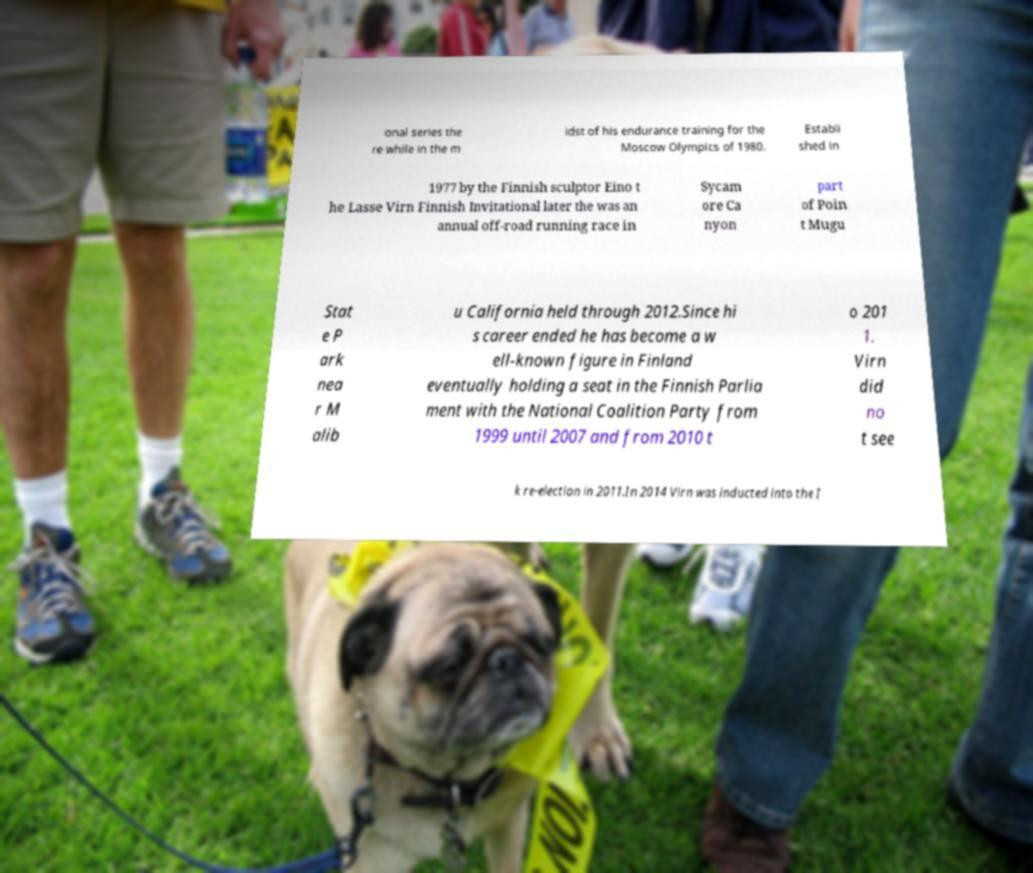Could you extract and type out the text from this image? onal series the re while in the m idst of his endurance training for the Moscow Olympics of 1980. Establi shed in 1977 by the Finnish sculptor Eino t he Lasse Virn Finnish Invitational later the was an annual off-road running race in Sycam ore Ca nyon part of Poin t Mugu Stat e P ark nea r M alib u California held through 2012.Since hi s career ended he has become a w ell-known figure in Finland eventually holding a seat in the Finnish Parlia ment with the National Coalition Party from 1999 until 2007 and from 2010 t o 201 1. Virn did no t see k re-election in 2011.In 2014 Virn was inducted into the I 